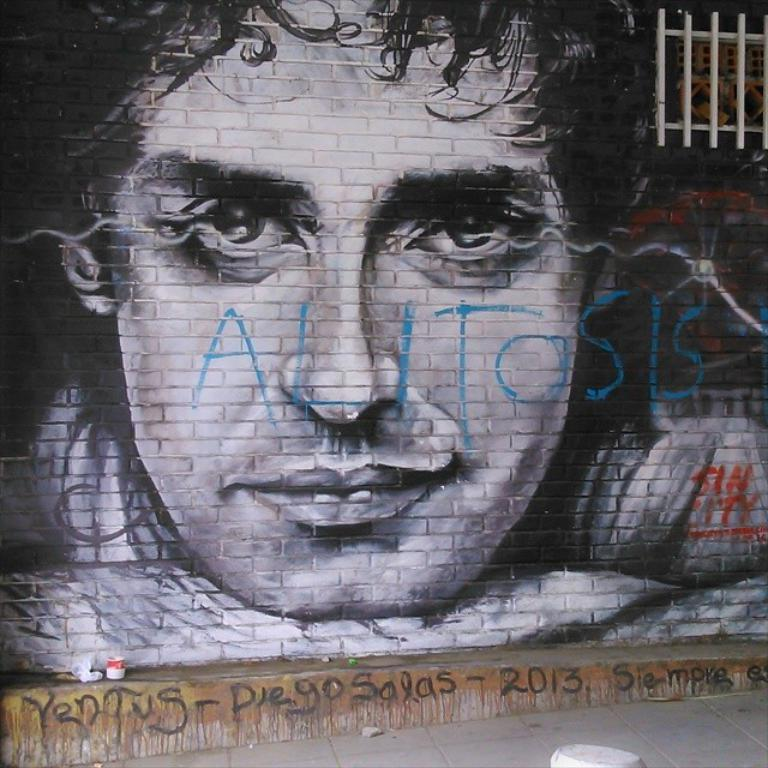What is depicted on the wall in the image? There is a sketch of a man on the wall. What is the facial expression of the man in the sketch? The man in the sketch is smiling. What architectural feature can be seen in the image? There is a window in the image. What is written at the bottom of the image? There is writing at the bottom of the image. How many houses are visible in the image? There are no houses visible in the image; it features a sketch of a man on the wall. What type of vase is placed on the table in the image? There is no vase present in the image. 